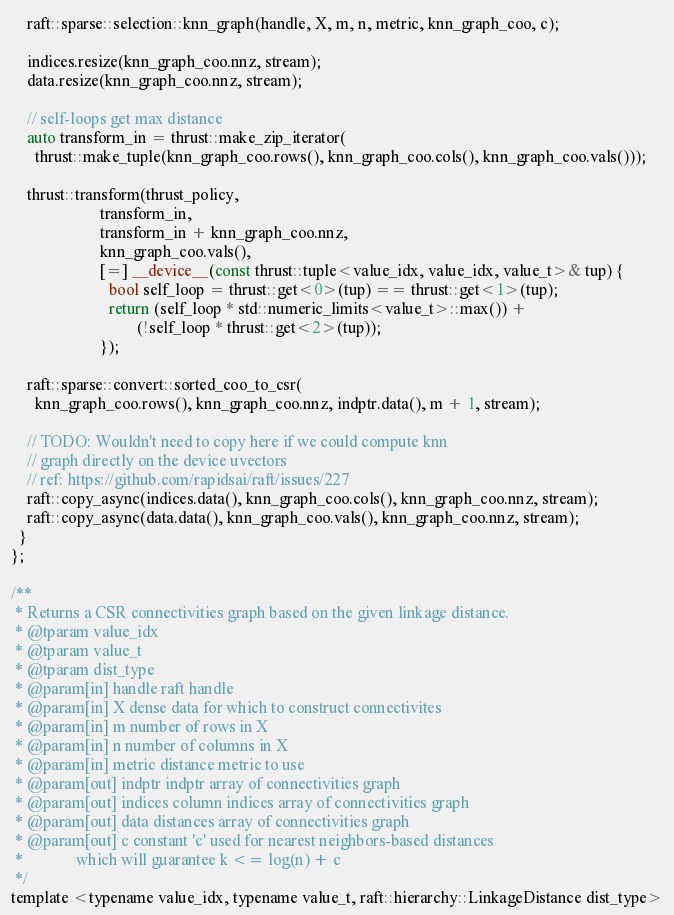Convert code to text. <code><loc_0><loc_0><loc_500><loc_500><_Cuda_>    raft::sparse::selection::knn_graph(handle, X, m, n, metric, knn_graph_coo, c);

    indices.resize(knn_graph_coo.nnz, stream);
    data.resize(knn_graph_coo.nnz, stream);

    // self-loops get max distance
    auto transform_in = thrust::make_zip_iterator(
      thrust::make_tuple(knn_graph_coo.rows(), knn_graph_coo.cols(), knn_graph_coo.vals()));

    thrust::transform(thrust_policy,
                      transform_in,
                      transform_in + knn_graph_coo.nnz,
                      knn_graph_coo.vals(),
                      [=] __device__(const thrust::tuple<value_idx, value_idx, value_t>& tup) {
                        bool self_loop = thrust::get<0>(tup) == thrust::get<1>(tup);
                        return (self_loop * std::numeric_limits<value_t>::max()) +
                               (!self_loop * thrust::get<2>(tup));
                      });

    raft::sparse::convert::sorted_coo_to_csr(
      knn_graph_coo.rows(), knn_graph_coo.nnz, indptr.data(), m + 1, stream);

    // TODO: Wouldn't need to copy here if we could compute knn
    // graph directly on the device uvectors
    // ref: https://github.com/rapidsai/raft/issues/227
    raft::copy_async(indices.data(), knn_graph_coo.cols(), knn_graph_coo.nnz, stream);
    raft::copy_async(data.data(), knn_graph_coo.vals(), knn_graph_coo.nnz, stream);
  }
};

/**
 * Returns a CSR connectivities graph based on the given linkage distance.
 * @tparam value_idx
 * @tparam value_t
 * @tparam dist_type
 * @param[in] handle raft handle
 * @param[in] X dense data for which to construct connectivites
 * @param[in] m number of rows in X
 * @param[in] n number of columns in X
 * @param[in] metric distance metric to use
 * @param[out] indptr indptr array of connectivities graph
 * @param[out] indices column indices array of connectivities graph
 * @param[out] data distances array of connectivities graph
 * @param[out] c constant 'c' used for nearest neighbors-based distances
 *             which will guarantee k <= log(n) + c
 */
template <typename value_idx, typename value_t, raft::hierarchy::LinkageDistance dist_type></code> 